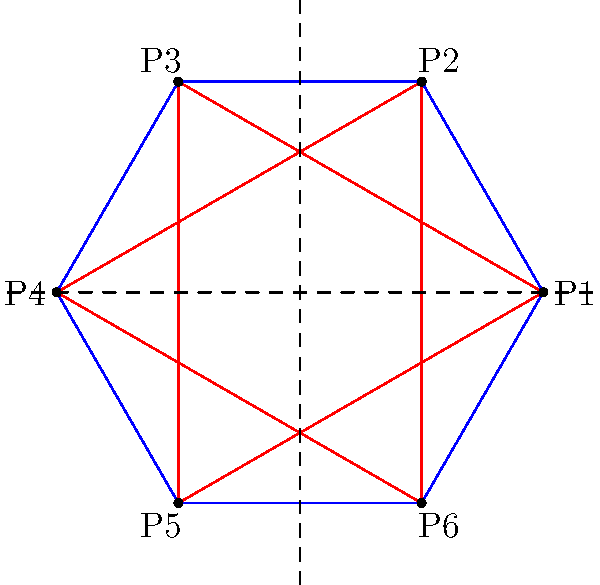In this traditional hexagonal pattern often found in Islamic art, how many lines of symmetry does the figure have? To determine the number of lines of symmetry in this hexagonal pattern, we need to consider the following steps:

1. Rotational symmetry: The hexagon has 6-fold rotational symmetry, which means it can be rotated by 60° (360°/6) and still look the same.

2. Lines through vertices: There are 3 lines of symmetry that pass through opposite vertices of the hexagon:
   - Line through P1 and P4
   - Line through P2 and P5
   - Line through P3 and P6

3. Lines through midpoints of sides: There are 3 lines of symmetry that pass through the midpoints of opposite sides of the hexagon:
   - Vertical line (y-axis)
   - Two lines at 60° angles to the vertical

4. Inner triangles: The red triangles inside the hexagon also exhibit the same symmetry as the hexagon itself.

5. Total lines of symmetry: The number of lines of symmetry is the sum of the lines through vertices and the lines through midpoints of sides:
   3 (through vertices) + 3 (through midpoints) = 6 total lines of symmetry

This hexagonal pattern, common in Islamic art and other cultural designs, demonstrates perfect 6-fold symmetry, reflecting the mathematical precision often found in traditional patterns across various cultures.
Answer: 6 